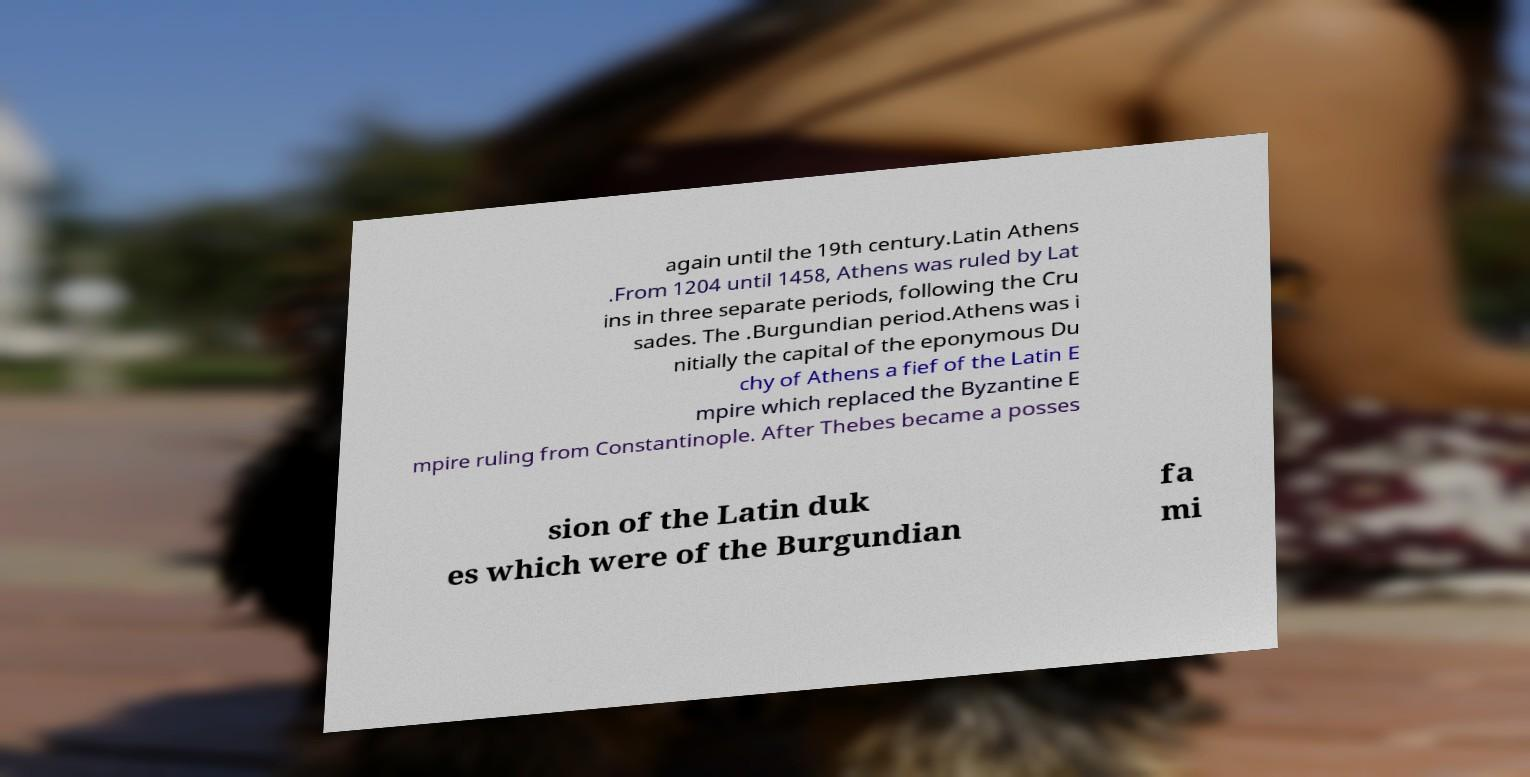Please identify and transcribe the text found in this image. again until the 19th century.Latin Athens .From 1204 until 1458, Athens was ruled by Lat ins in three separate periods, following the Cru sades. The .Burgundian period.Athens was i nitially the capital of the eponymous Du chy of Athens a fief of the Latin E mpire which replaced the Byzantine E mpire ruling from Constantinople. After Thebes became a posses sion of the Latin duk es which were of the Burgundian fa mi 